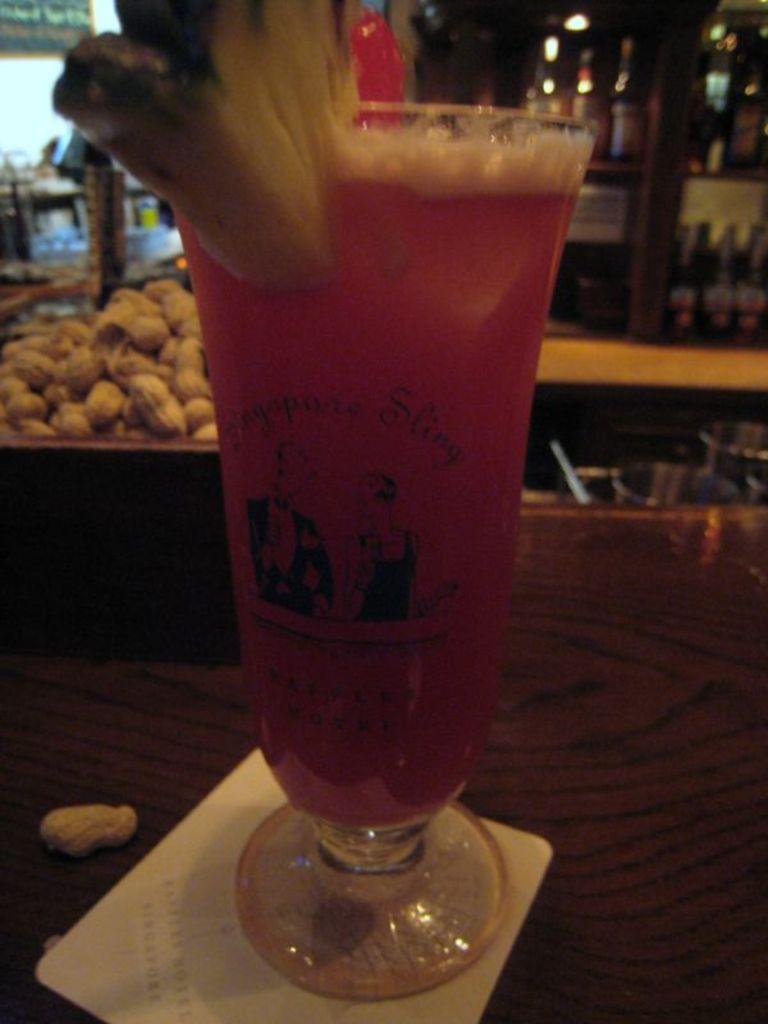Could you give a brief overview of what you see in this image? In this picture I can see the wine glass. I can see peanut shells on the right side. I can see the table. I can see alcohol bottles on the rack. 